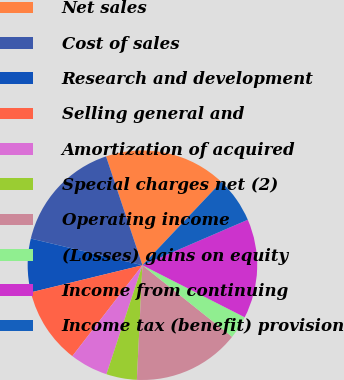<chart> <loc_0><loc_0><loc_500><loc_500><pie_chart><fcel>Net sales<fcel>Cost of sales<fcel>Research and development<fcel>Selling general and<fcel>Amortization of acquired<fcel>Special charges net (2)<fcel>Operating income<fcel>(Losses) gains on equity<fcel>Income from continuing<fcel>Income tax (benefit) provision<nl><fcel>17.2%<fcel>16.13%<fcel>7.53%<fcel>10.75%<fcel>5.38%<fcel>4.3%<fcel>15.05%<fcel>3.23%<fcel>13.98%<fcel>6.45%<nl></chart> 